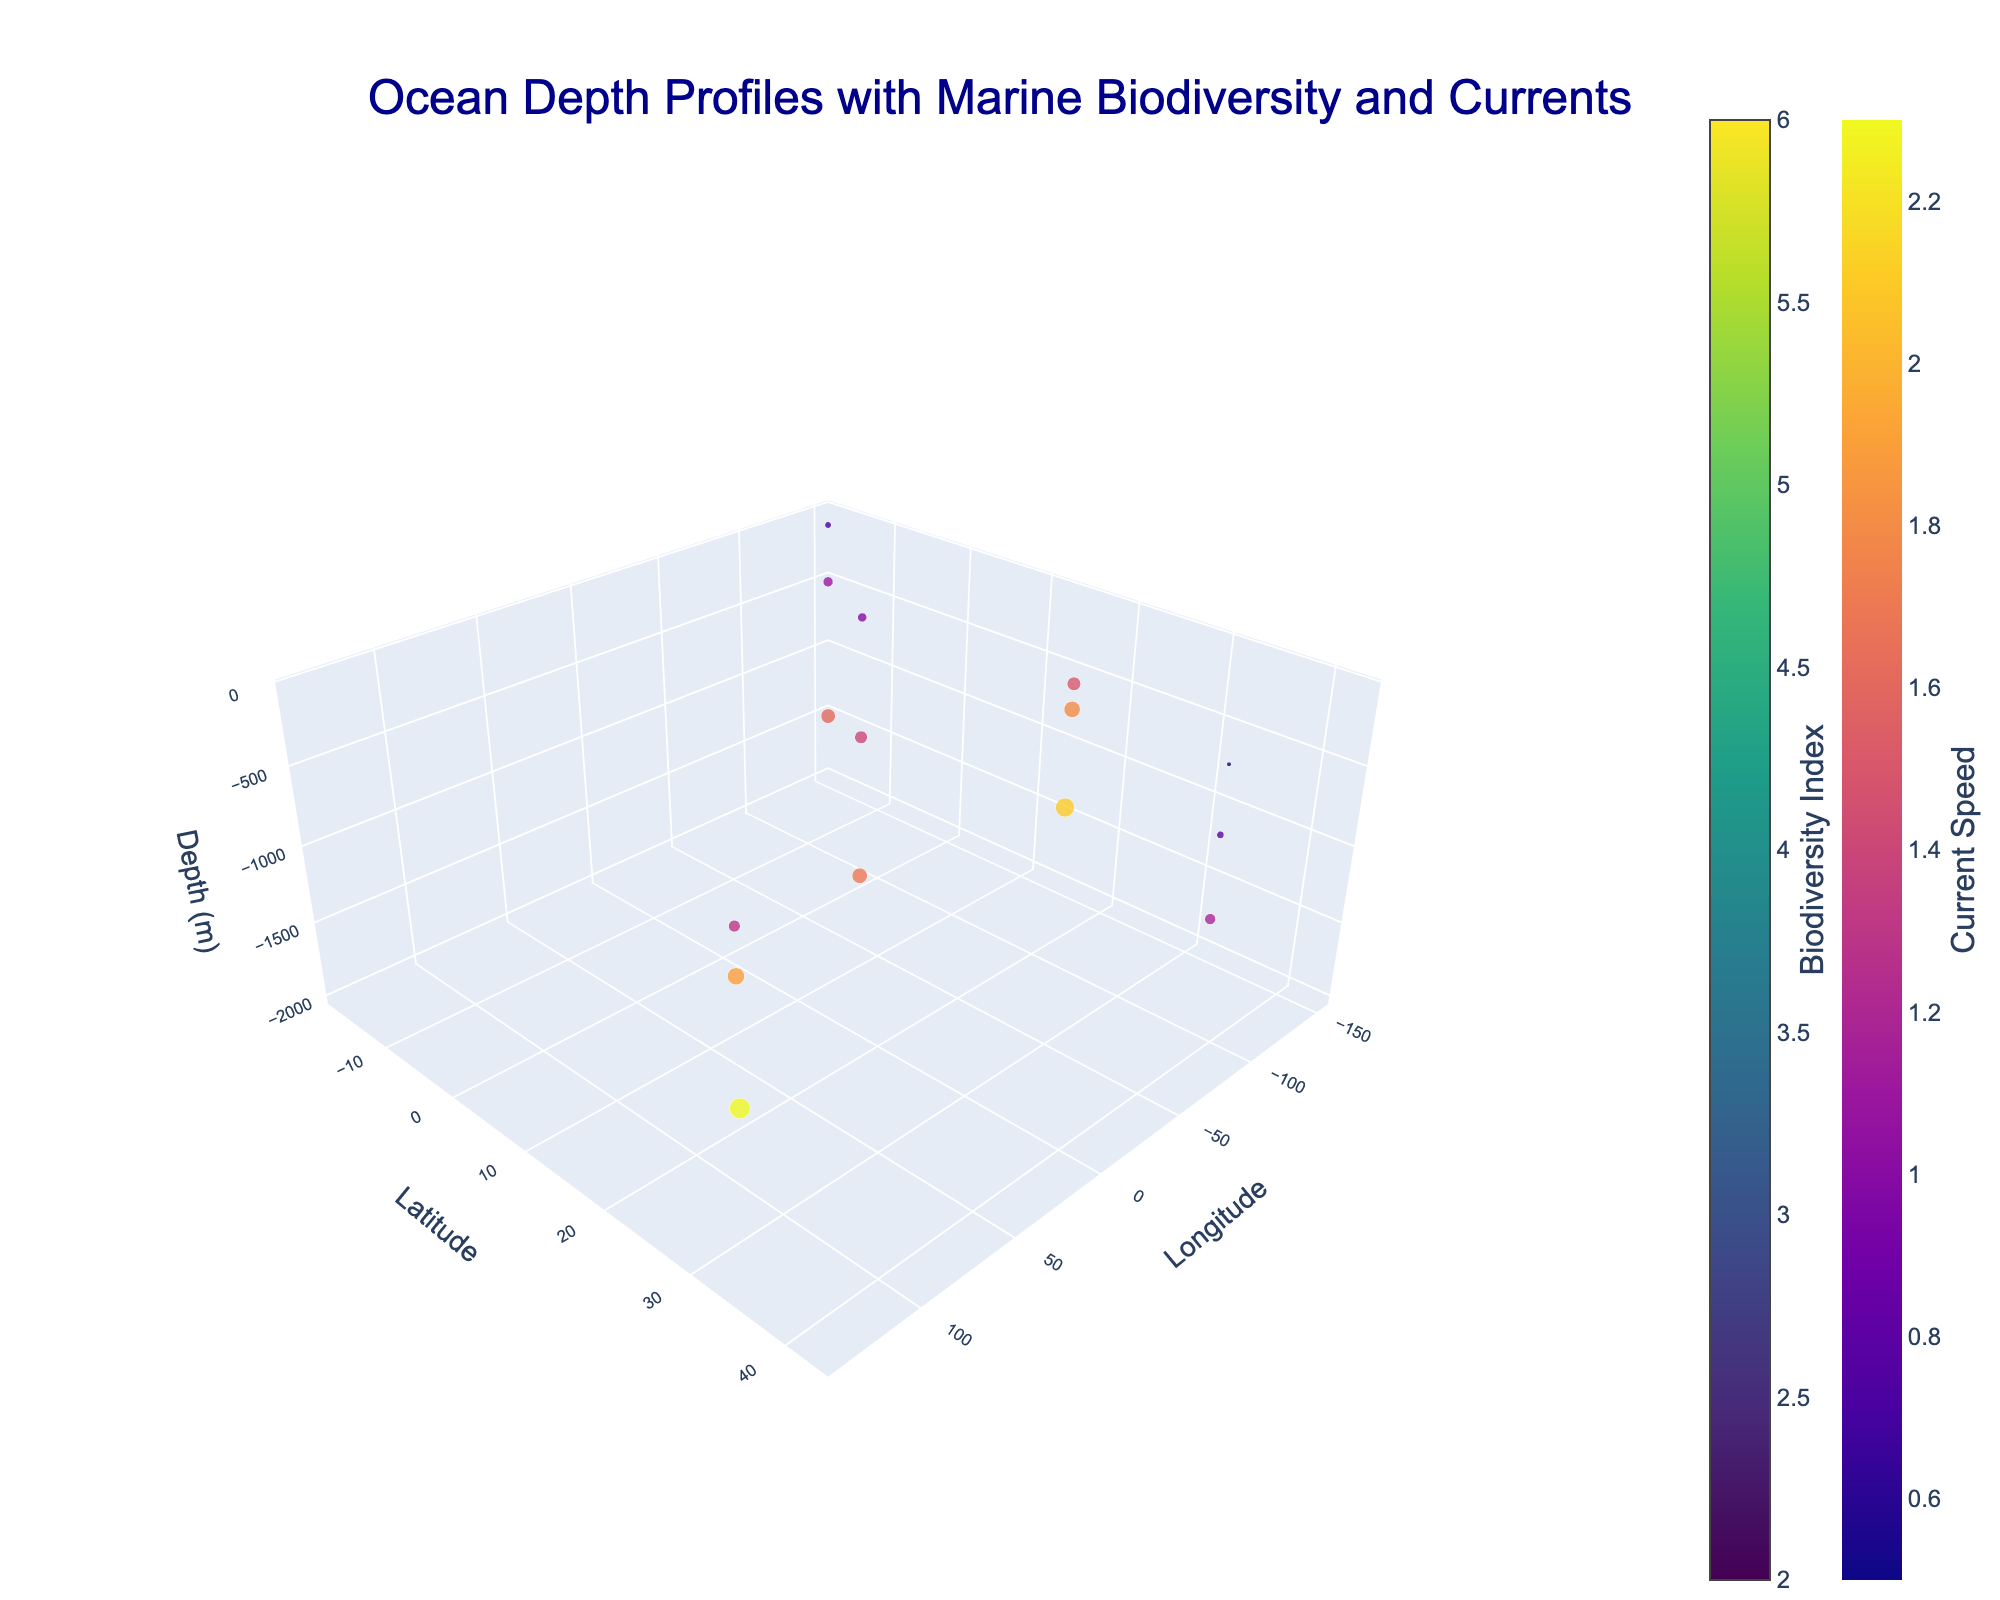What is the title of the figure? The title of the figure is usually displayed at the top of the plot. By looking at the plot, the title can be directly read.
Answer: Ocean Depth Profiles with Marine Biodiversity and Currents What are the axes labels in this plot? Axes labels are usually found next to the respective axis. By looking at the plot, the axis labels can be read directly.
Answer: Longitude, Latitude, Depth (m) Describe the color scale used for the Biodiversity Index. Look at the colorbar next to the plot that indicates "Biodiversity Index". The scale is likely to be a gradient, and the name of the colorscale will be indicated.
Answer: Viridis What determines the size of the scatter plot markers? By looking at the scatter plot markers and their legend, the size of the markers is often related to a variable indicated in the plot’s description. In this case, we'll examine the markers in the plot to see what variable might affect their size.
Answer: Current Speed How does biodiversity change with depth at the coordinates (-80.2, 25.7)? The latitude and longitude of (-80.2, 25.7) should be found in the plot, and the Biodiversity Index values at different depths can be identified by following the color changes and legends in the figure.
Answer: It decreases with depth At which location can we observe the highest biodiversity index? Look at different locations in the plot and find the point with the highest color intensity corresponding to the Biodiversity Index scale.
Answer: -90.1, -0.5, at -200m depth How does current speed affect biodiversity at the same depth? Identify plots at the same depth and compare the biodiversity index with the size and color of the scatter plot markers which represent current speed. Analyze if higher current speed correlates with higher or lower biodiversity values.
Answer: Generally, higher current speeds correspond to higher biodiversity Compare the depth profiles of marine biodiversity at (-70.5, 42.3) vs. (135.7, 33.8). Which one shows higher biodiversity at greater depths? Look at the points on the plot for both sets of coordinates and assess the biodiversity values at deeper levels (e.g., -1000m). Determine which one has higher values.
Answer: (135.7, 33.8) What patterns do you observe in the distribution of current speeds across different depths? Assess the distribution of scatter plot markers' sizes and colors across different depths to identify any noticeable patterns related to current speed variations.
Answer: Generally, current speed increases with depth Which depth level has the most data points? By observing the density of points along the depth axis in the plot, you can determine which depth has the most data points.
Answer: -1000m 